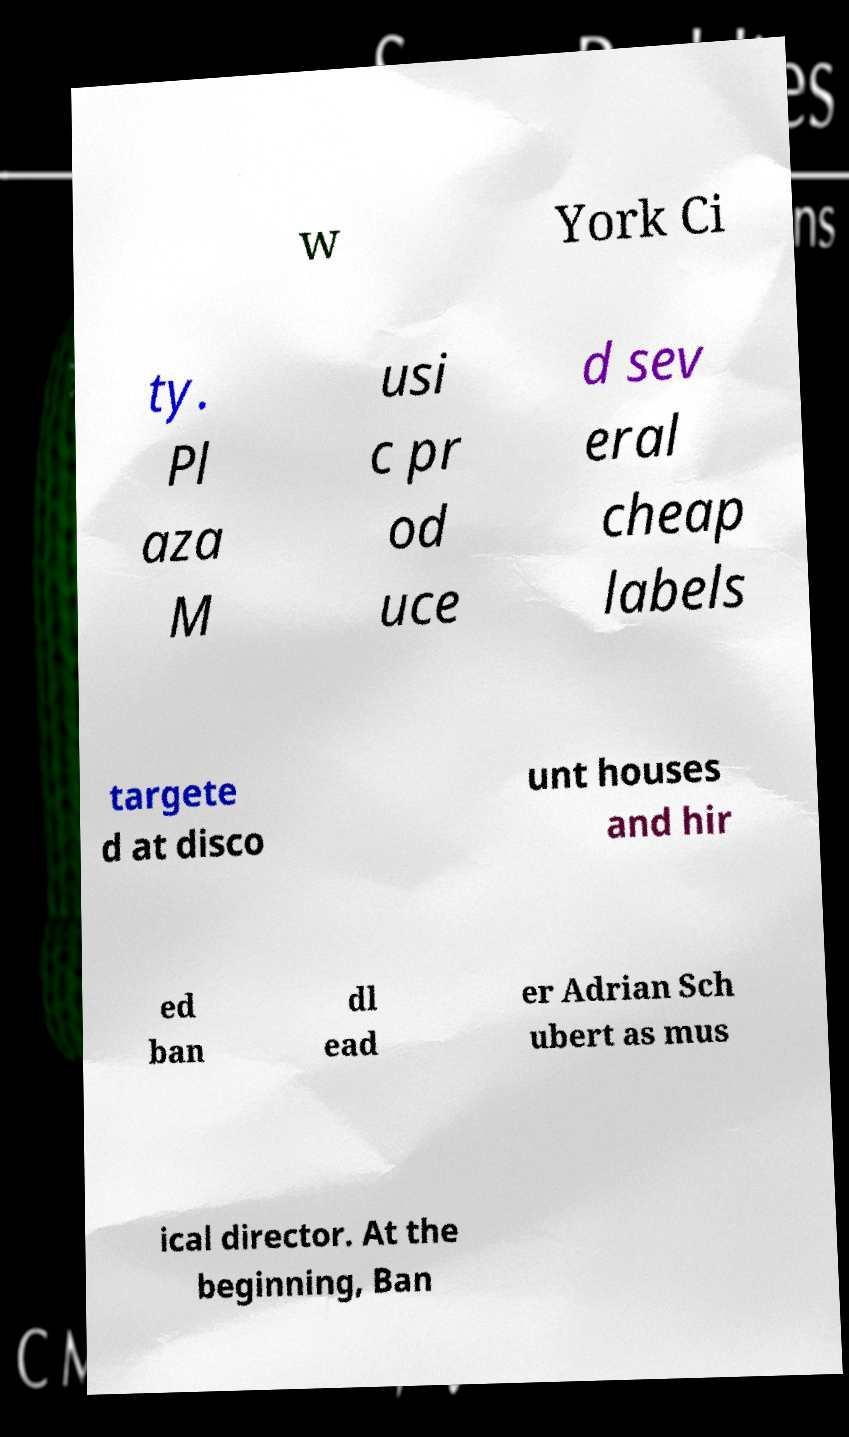Please identify and transcribe the text found in this image. w York Ci ty. Pl aza M usi c pr od uce d sev eral cheap labels targete d at disco unt houses and hir ed ban dl ead er Adrian Sch ubert as mus ical director. At the beginning, Ban 